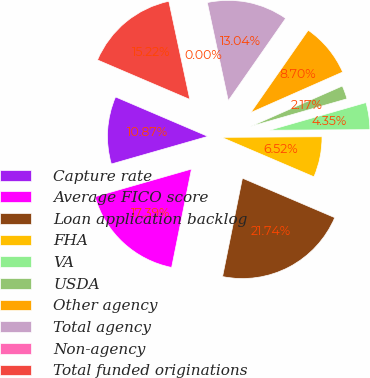Convert chart. <chart><loc_0><loc_0><loc_500><loc_500><pie_chart><fcel>Capture rate<fcel>Average FICO score<fcel>Loan application backlog<fcel>FHA<fcel>VA<fcel>USDA<fcel>Other agency<fcel>Total agency<fcel>Non-agency<fcel>Total funded originations<nl><fcel>10.87%<fcel>17.39%<fcel>21.74%<fcel>6.52%<fcel>4.35%<fcel>2.17%<fcel>8.7%<fcel>13.04%<fcel>0.0%<fcel>15.22%<nl></chart> 